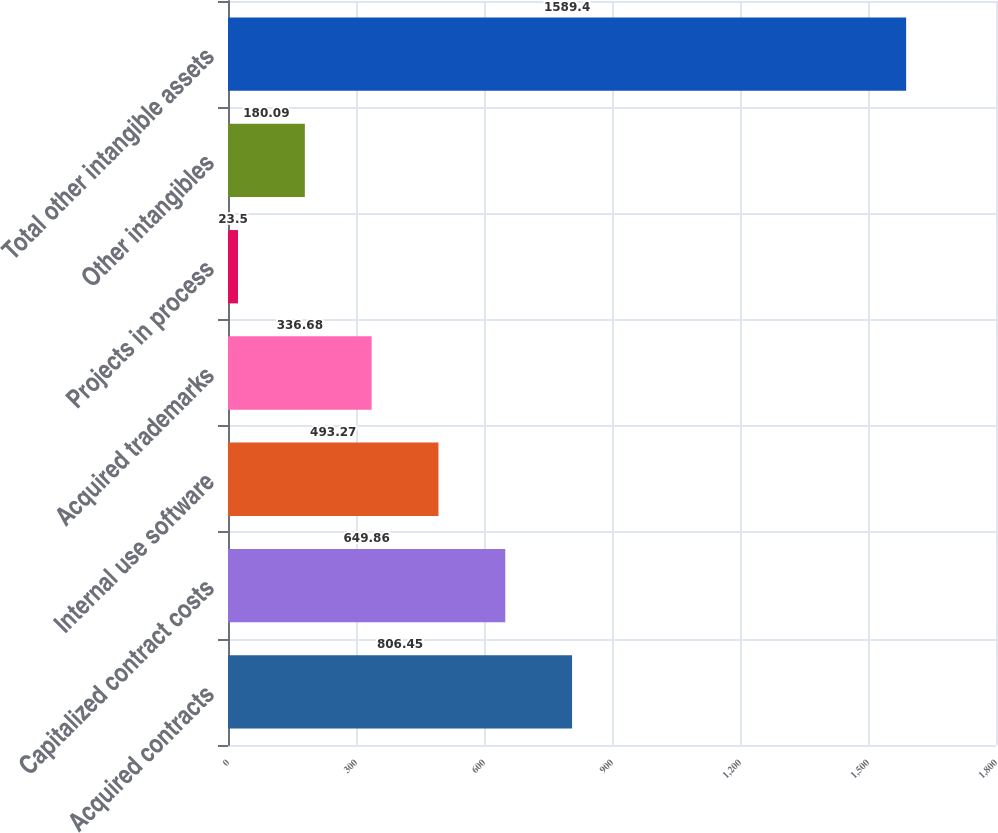<chart> <loc_0><loc_0><loc_500><loc_500><bar_chart><fcel>Acquired contracts<fcel>Capitalized contract costs<fcel>Internal use software<fcel>Acquired trademarks<fcel>Projects in process<fcel>Other intangibles<fcel>Total other intangible assets<nl><fcel>806.45<fcel>649.86<fcel>493.27<fcel>336.68<fcel>23.5<fcel>180.09<fcel>1589.4<nl></chart> 